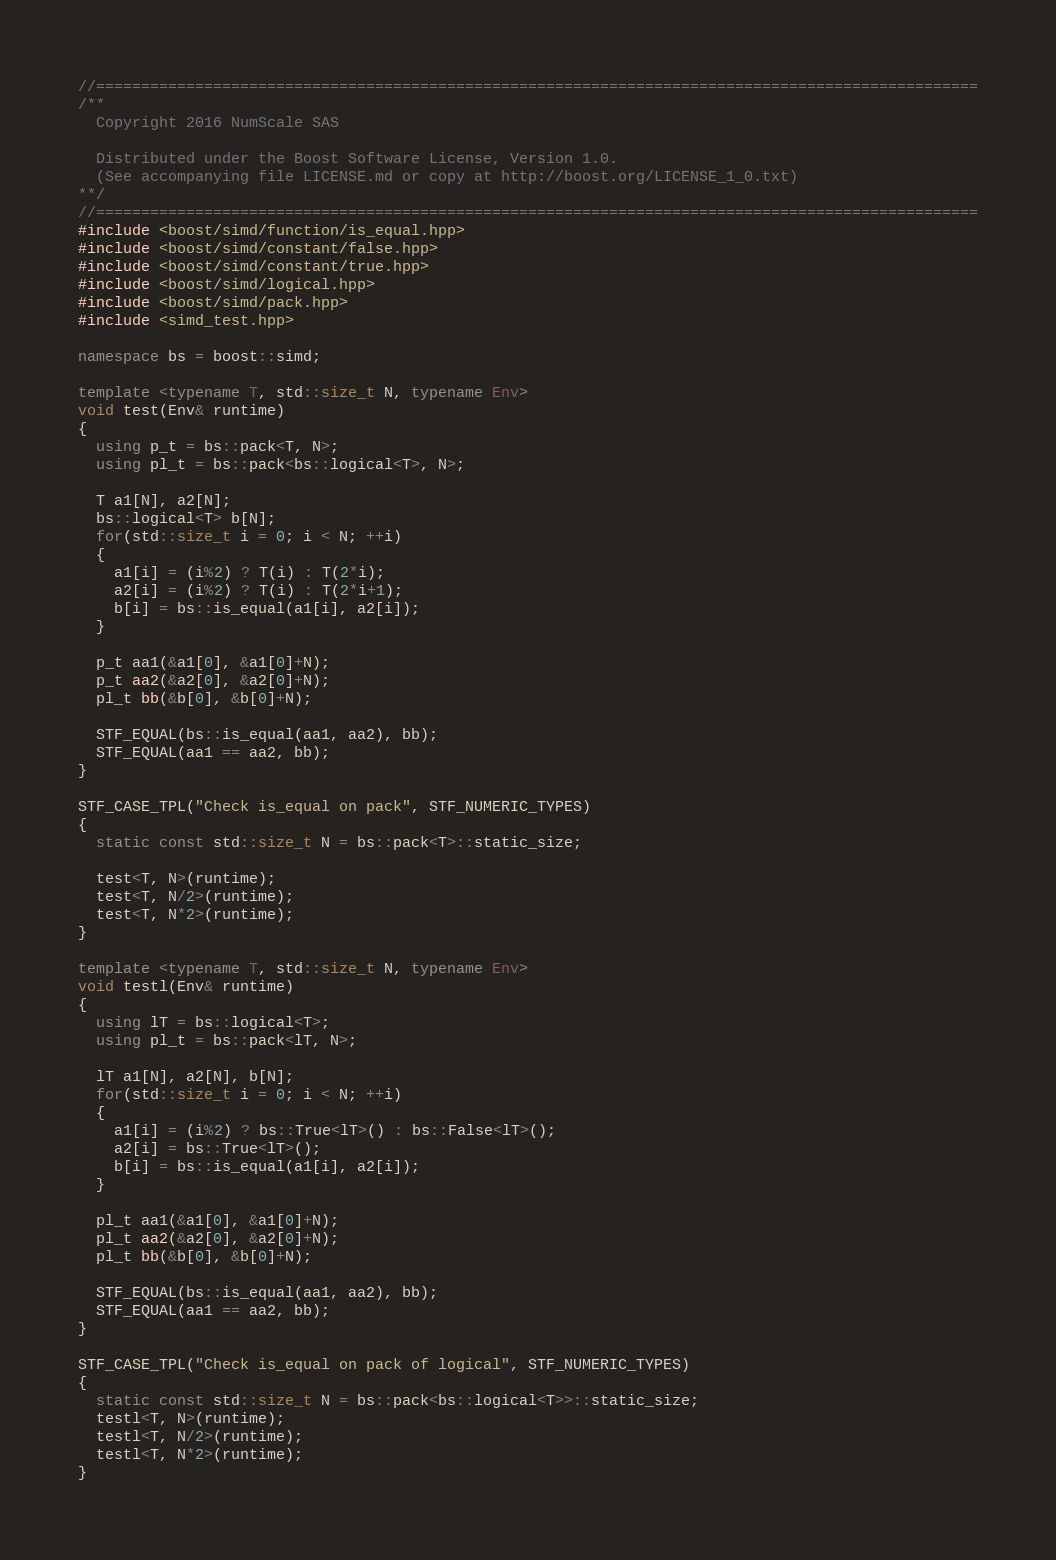<code> <loc_0><loc_0><loc_500><loc_500><_C++_>//==================================================================================================
/**
  Copyright 2016 NumScale SAS

  Distributed under the Boost Software License, Version 1.0.
  (See accompanying file LICENSE.md or copy at http://boost.org/LICENSE_1_0.txt)
**/
//==================================================================================================
#include <boost/simd/function/is_equal.hpp>
#include <boost/simd/constant/false.hpp>
#include <boost/simd/constant/true.hpp>
#include <boost/simd/logical.hpp>
#include <boost/simd/pack.hpp>
#include <simd_test.hpp>

namespace bs = boost::simd;

template <typename T, std::size_t N, typename Env>
void test(Env& runtime)
{
  using p_t = bs::pack<T, N>;
  using pl_t = bs::pack<bs::logical<T>, N>;

  T a1[N], a2[N];
  bs::logical<T> b[N];
  for(std::size_t i = 0; i < N; ++i)
  {
    a1[i] = (i%2) ? T(i) : T(2*i);
    a2[i] = (i%2) ? T(i) : T(2*i+1);
    b[i] = bs::is_equal(a1[i], a2[i]);
  }

  p_t aa1(&a1[0], &a1[0]+N);
  p_t aa2(&a2[0], &a2[0]+N);
  pl_t bb(&b[0], &b[0]+N);

  STF_EQUAL(bs::is_equal(aa1, aa2), bb);
  STF_EQUAL(aa1 == aa2, bb);
}

STF_CASE_TPL("Check is_equal on pack", STF_NUMERIC_TYPES)
{
  static const std::size_t N = bs::pack<T>::static_size;

  test<T, N>(runtime);
  test<T, N/2>(runtime);
  test<T, N*2>(runtime);
}

template <typename T, std::size_t N, typename Env>
void testl(Env& runtime)
{
  using lT = bs::logical<T>;
  using pl_t = bs::pack<lT, N>;

  lT a1[N], a2[N], b[N];
  for(std::size_t i = 0; i < N; ++i)
  {
    a1[i] = (i%2) ? bs::True<lT>() : bs::False<lT>();
    a2[i] = bs::True<lT>();
    b[i] = bs::is_equal(a1[i], a2[i]);
  }

  pl_t aa1(&a1[0], &a1[0]+N);
  pl_t aa2(&a2[0], &a2[0]+N);
  pl_t bb(&b[0], &b[0]+N);

  STF_EQUAL(bs::is_equal(aa1, aa2), bb);
  STF_EQUAL(aa1 == aa2, bb);
}

STF_CASE_TPL("Check is_equal on pack of logical", STF_NUMERIC_TYPES)
{
  static const std::size_t N = bs::pack<bs::logical<T>>::static_size;
  testl<T, N>(runtime);
  testl<T, N/2>(runtime);
  testl<T, N*2>(runtime);
}
</code> 